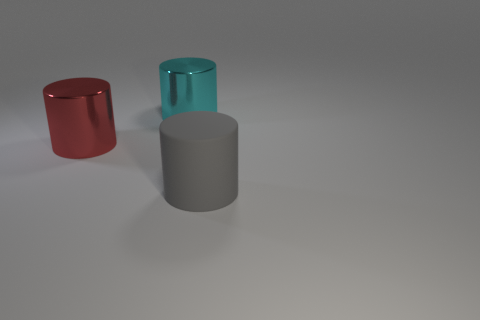There is another big cyan object that is the same shape as the big rubber object; what is its material?
Provide a short and direct response. Metal. There is a shiny thing that is the same size as the red shiny cylinder; what color is it?
Your answer should be very brief. Cyan. Are there an equal number of red objects that are in front of the large gray cylinder and big purple shiny cylinders?
Your answer should be compact. Yes. What color is the cylinder that is in front of the metallic thing to the left of the cyan thing?
Offer a very short reply. Gray. There is a object in front of the thing to the left of the cyan metal thing; what is its size?
Keep it short and to the point. Large. What number of other things are there of the same size as the red cylinder?
Ensure brevity in your answer.  2. There is a metal cylinder that is on the right side of the big cylinder that is on the left side of the large thing behind the red shiny cylinder; what is its color?
Ensure brevity in your answer.  Cyan. How many other objects are there of the same shape as the big rubber thing?
Offer a terse response. 2. What is the shape of the object that is in front of the red thing?
Your answer should be compact. Cylinder. Is there a large cylinder that is behind the big metal thing that is in front of the cyan object?
Give a very brief answer. Yes. 